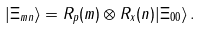Convert formula to latex. <formula><loc_0><loc_0><loc_500><loc_500>| \Xi _ { m n } \rangle = { R } _ { p } ( m ) \otimes { R } _ { x } ( n ) | \Xi _ { 0 0 } \rangle \, .</formula> 